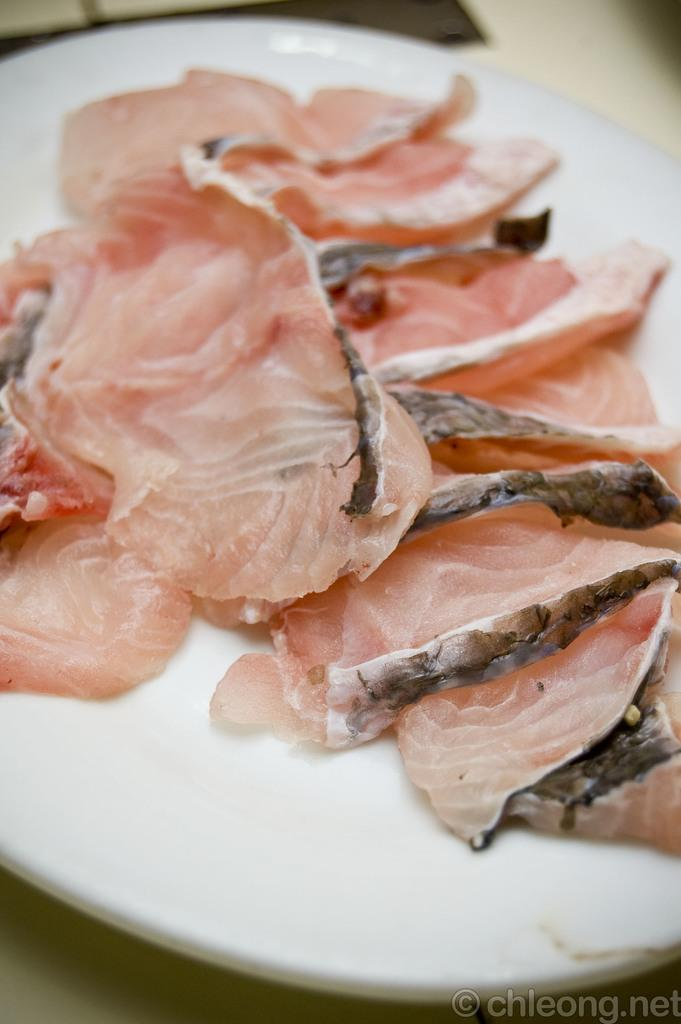What is on the plate that is visible in the image? There is meat on a plate in the image. Where is the plate located in the image? The plate is placed on a table in the image. What can be seen on the right side of the image? There is some text on the right side of the image. What type of crib is visible in the image? There is no crib present in the image. How many arms are visible in the image? The image does not depict any arms; it features a plate of meat, a table, and some text. 